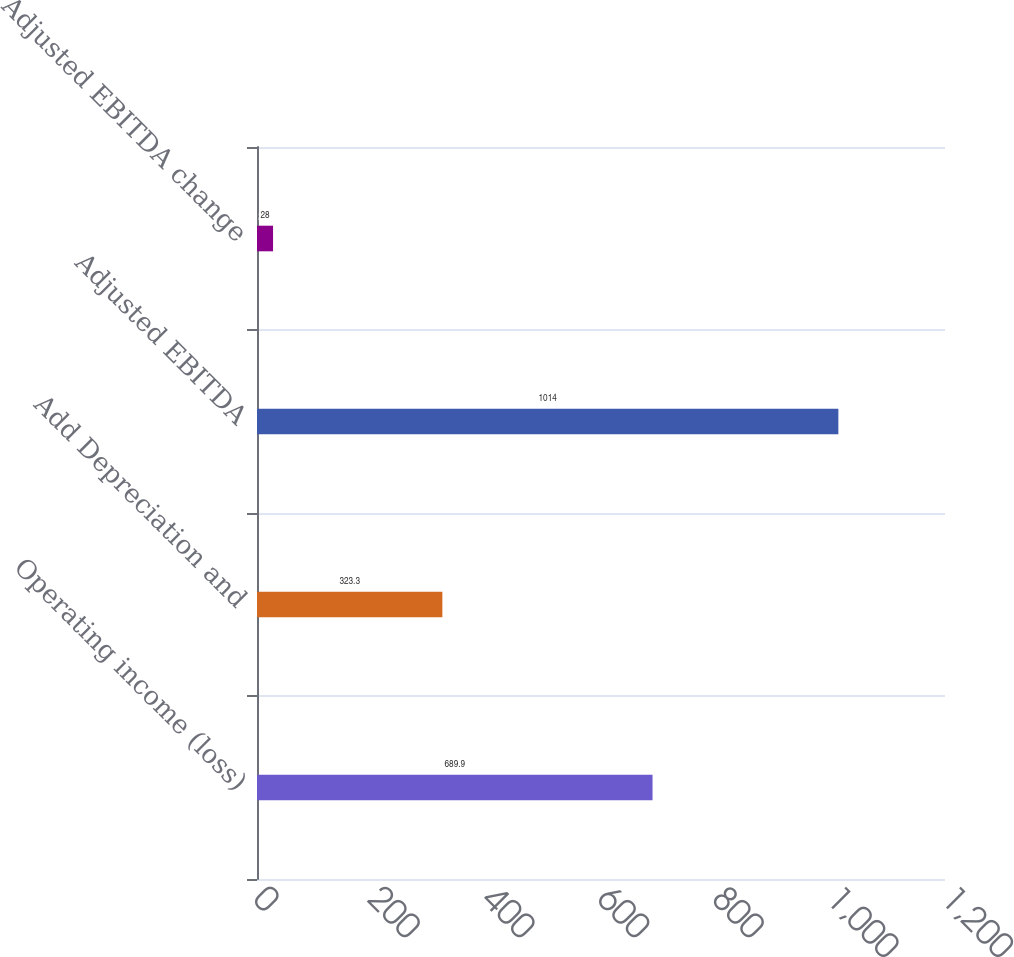Convert chart to OTSL. <chart><loc_0><loc_0><loc_500><loc_500><bar_chart><fcel>Operating income (loss)<fcel>Add Depreciation and<fcel>Adjusted EBITDA<fcel>Adjusted EBITDA change<nl><fcel>689.9<fcel>323.3<fcel>1014<fcel>28<nl></chart> 